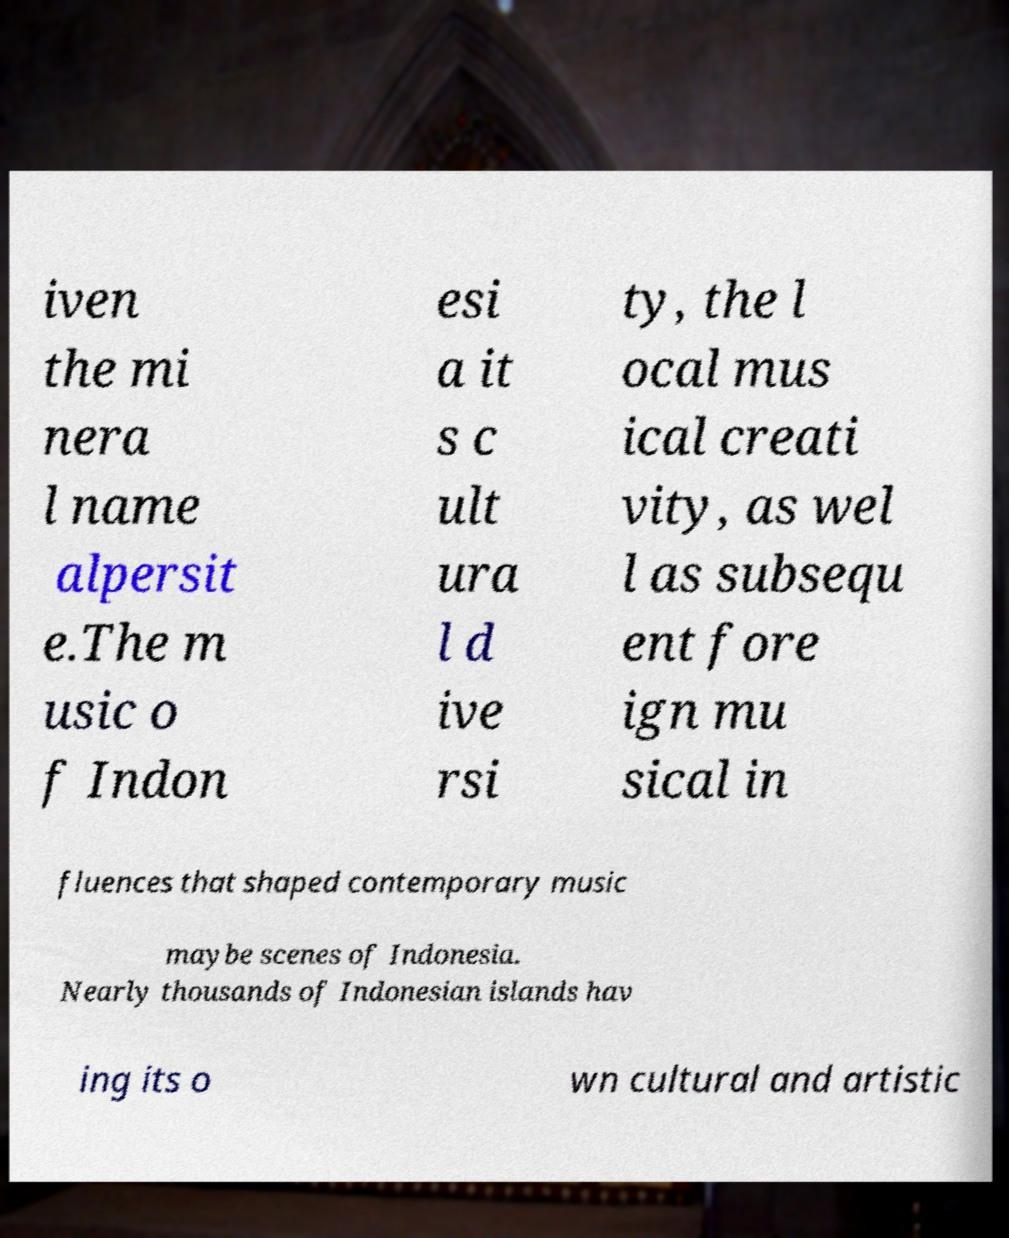Could you assist in decoding the text presented in this image and type it out clearly? iven the mi nera l name alpersit e.The m usic o f Indon esi a it s c ult ura l d ive rsi ty, the l ocal mus ical creati vity, as wel l as subsequ ent fore ign mu sical in fluences that shaped contemporary music maybe scenes of Indonesia. Nearly thousands of Indonesian islands hav ing its o wn cultural and artistic 